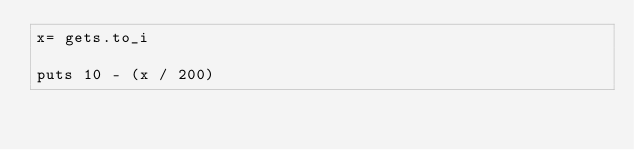Convert code to text. <code><loc_0><loc_0><loc_500><loc_500><_Ruby_>x= gets.to_i

puts 10 - (x / 200)


</code> 